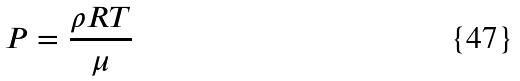<formula> <loc_0><loc_0><loc_500><loc_500>P = \frac { \rho R T } { \mu }</formula> 